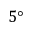<formula> <loc_0><loc_0><loc_500><loc_500>5 \text  degree</formula> 